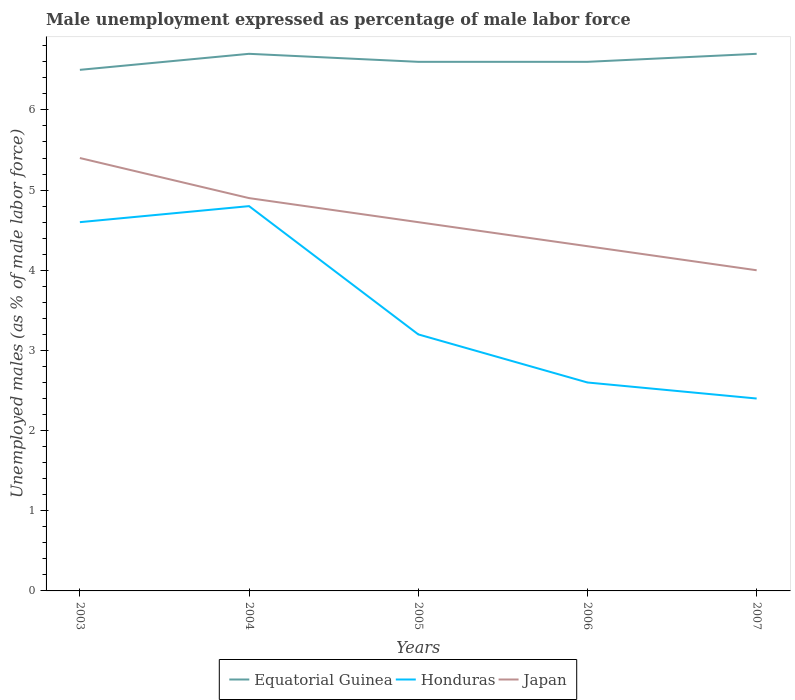Across all years, what is the maximum unemployment in males in in Honduras?
Offer a terse response. 2.4. What is the total unemployment in males in in Honduras in the graph?
Keep it short and to the point. 2.4. What is the difference between the highest and the second highest unemployment in males in in Equatorial Guinea?
Ensure brevity in your answer.  0.2. How many years are there in the graph?
Keep it short and to the point. 5. What is the difference between two consecutive major ticks on the Y-axis?
Make the answer very short. 1. Does the graph contain grids?
Keep it short and to the point. No. How many legend labels are there?
Make the answer very short. 3. How are the legend labels stacked?
Your answer should be compact. Horizontal. What is the title of the graph?
Give a very brief answer. Male unemployment expressed as percentage of male labor force. What is the label or title of the Y-axis?
Offer a very short reply. Unemployed males (as % of male labor force). What is the Unemployed males (as % of male labor force) in Equatorial Guinea in 2003?
Ensure brevity in your answer.  6.5. What is the Unemployed males (as % of male labor force) in Honduras in 2003?
Provide a succinct answer. 4.6. What is the Unemployed males (as % of male labor force) of Japan in 2003?
Make the answer very short. 5.4. What is the Unemployed males (as % of male labor force) of Equatorial Guinea in 2004?
Give a very brief answer. 6.7. What is the Unemployed males (as % of male labor force) in Honduras in 2004?
Give a very brief answer. 4.8. What is the Unemployed males (as % of male labor force) in Japan in 2004?
Make the answer very short. 4.9. What is the Unemployed males (as % of male labor force) in Equatorial Guinea in 2005?
Provide a succinct answer. 6.6. What is the Unemployed males (as % of male labor force) of Honduras in 2005?
Your answer should be compact. 3.2. What is the Unemployed males (as % of male labor force) of Japan in 2005?
Offer a very short reply. 4.6. What is the Unemployed males (as % of male labor force) of Equatorial Guinea in 2006?
Provide a short and direct response. 6.6. What is the Unemployed males (as % of male labor force) in Honduras in 2006?
Give a very brief answer. 2.6. What is the Unemployed males (as % of male labor force) of Japan in 2006?
Offer a very short reply. 4.3. What is the Unemployed males (as % of male labor force) in Equatorial Guinea in 2007?
Your answer should be compact. 6.7. What is the Unemployed males (as % of male labor force) in Honduras in 2007?
Give a very brief answer. 2.4. Across all years, what is the maximum Unemployed males (as % of male labor force) in Equatorial Guinea?
Offer a terse response. 6.7. Across all years, what is the maximum Unemployed males (as % of male labor force) in Honduras?
Offer a very short reply. 4.8. Across all years, what is the maximum Unemployed males (as % of male labor force) in Japan?
Offer a terse response. 5.4. Across all years, what is the minimum Unemployed males (as % of male labor force) in Equatorial Guinea?
Offer a terse response. 6.5. Across all years, what is the minimum Unemployed males (as % of male labor force) in Honduras?
Provide a succinct answer. 2.4. What is the total Unemployed males (as % of male labor force) in Equatorial Guinea in the graph?
Your answer should be compact. 33.1. What is the total Unemployed males (as % of male labor force) in Honduras in the graph?
Ensure brevity in your answer.  17.6. What is the total Unemployed males (as % of male labor force) of Japan in the graph?
Ensure brevity in your answer.  23.2. What is the difference between the Unemployed males (as % of male labor force) in Honduras in 2003 and that in 2004?
Your answer should be compact. -0.2. What is the difference between the Unemployed males (as % of male labor force) in Japan in 2003 and that in 2004?
Make the answer very short. 0.5. What is the difference between the Unemployed males (as % of male labor force) of Honduras in 2003 and that in 2005?
Offer a terse response. 1.4. What is the difference between the Unemployed males (as % of male labor force) in Honduras in 2003 and that in 2006?
Offer a terse response. 2. What is the difference between the Unemployed males (as % of male labor force) of Japan in 2003 and that in 2006?
Give a very brief answer. 1.1. What is the difference between the Unemployed males (as % of male labor force) in Japan in 2003 and that in 2007?
Offer a very short reply. 1.4. What is the difference between the Unemployed males (as % of male labor force) of Equatorial Guinea in 2004 and that in 2005?
Give a very brief answer. 0.1. What is the difference between the Unemployed males (as % of male labor force) in Equatorial Guinea in 2004 and that in 2006?
Offer a terse response. 0.1. What is the difference between the Unemployed males (as % of male labor force) in Equatorial Guinea in 2004 and that in 2007?
Ensure brevity in your answer.  0. What is the difference between the Unemployed males (as % of male labor force) in Honduras in 2004 and that in 2007?
Give a very brief answer. 2.4. What is the difference between the Unemployed males (as % of male labor force) in Japan in 2004 and that in 2007?
Keep it short and to the point. 0.9. What is the difference between the Unemployed males (as % of male labor force) of Equatorial Guinea in 2005 and that in 2006?
Offer a terse response. 0. What is the difference between the Unemployed males (as % of male labor force) of Equatorial Guinea in 2005 and that in 2007?
Ensure brevity in your answer.  -0.1. What is the difference between the Unemployed males (as % of male labor force) of Equatorial Guinea in 2006 and that in 2007?
Offer a very short reply. -0.1. What is the difference between the Unemployed males (as % of male labor force) of Honduras in 2006 and that in 2007?
Offer a very short reply. 0.2. What is the difference between the Unemployed males (as % of male labor force) of Japan in 2006 and that in 2007?
Your answer should be very brief. 0.3. What is the difference between the Unemployed males (as % of male labor force) in Honduras in 2003 and the Unemployed males (as % of male labor force) in Japan in 2004?
Your answer should be very brief. -0.3. What is the difference between the Unemployed males (as % of male labor force) in Equatorial Guinea in 2003 and the Unemployed males (as % of male labor force) in Honduras in 2005?
Offer a very short reply. 3.3. What is the difference between the Unemployed males (as % of male labor force) of Equatorial Guinea in 2003 and the Unemployed males (as % of male labor force) of Japan in 2005?
Provide a short and direct response. 1.9. What is the difference between the Unemployed males (as % of male labor force) of Equatorial Guinea in 2003 and the Unemployed males (as % of male labor force) of Honduras in 2007?
Offer a terse response. 4.1. What is the difference between the Unemployed males (as % of male labor force) of Equatorial Guinea in 2003 and the Unemployed males (as % of male labor force) of Japan in 2007?
Provide a short and direct response. 2.5. What is the difference between the Unemployed males (as % of male labor force) in Honduras in 2003 and the Unemployed males (as % of male labor force) in Japan in 2007?
Ensure brevity in your answer.  0.6. What is the difference between the Unemployed males (as % of male labor force) of Equatorial Guinea in 2004 and the Unemployed males (as % of male labor force) of Honduras in 2006?
Make the answer very short. 4.1. What is the difference between the Unemployed males (as % of male labor force) in Equatorial Guinea in 2004 and the Unemployed males (as % of male labor force) in Japan in 2006?
Make the answer very short. 2.4. What is the difference between the Unemployed males (as % of male labor force) in Equatorial Guinea in 2004 and the Unemployed males (as % of male labor force) in Honduras in 2007?
Give a very brief answer. 4.3. What is the difference between the Unemployed males (as % of male labor force) in Honduras in 2004 and the Unemployed males (as % of male labor force) in Japan in 2007?
Provide a succinct answer. 0.8. What is the difference between the Unemployed males (as % of male labor force) of Equatorial Guinea in 2005 and the Unemployed males (as % of male labor force) of Japan in 2006?
Provide a succinct answer. 2.3. What is the difference between the Unemployed males (as % of male labor force) in Honduras in 2005 and the Unemployed males (as % of male labor force) in Japan in 2006?
Your response must be concise. -1.1. What is the difference between the Unemployed males (as % of male labor force) of Equatorial Guinea in 2005 and the Unemployed males (as % of male labor force) of Japan in 2007?
Offer a terse response. 2.6. What is the difference between the Unemployed males (as % of male labor force) in Honduras in 2005 and the Unemployed males (as % of male labor force) in Japan in 2007?
Provide a succinct answer. -0.8. What is the difference between the Unemployed males (as % of male labor force) of Equatorial Guinea in 2006 and the Unemployed males (as % of male labor force) of Honduras in 2007?
Ensure brevity in your answer.  4.2. What is the difference between the Unemployed males (as % of male labor force) in Equatorial Guinea in 2006 and the Unemployed males (as % of male labor force) in Japan in 2007?
Offer a very short reply. 2.6. What is the difference between the Unemployed males (as % of male labor force) in Honduras in 2006 and the Unemployed males (as % of male labor force) in Japan in 2007?
Give a very brief answer. -1.4. What is the average Unemployed males (as % of male labor force) of Equatorial Guinea per year?
Make the answer very short. 6.62. What is the average Unemployed males (as % of male labor force) of Honduras per year?
Provide a succinct answer. 3.52. What is the average Unemployed males (as % of male labor force) in Japan per year?
Make the answer very short. 4.64. In the year 2003, what is the difference between the Unemployed males (as % of male labor force) in Equatorial Guinea and Unemployed males (as % of male labor force) in Honduras?
Your answer should be compact. 1.9. In the year 2003, what is the difference between the Unemployed males (as % of male labor force) in Honduras and Unemployed males (as % of male labor force) in Japan?
Offer a terse response. -0.8. In the year 2004, what is the difference between the Unemployed males (as % of male labor force) in Equatorial Guinea and Unemployed males (as % of male labor force) in Japan?
Make the answer very short. 1.8. In the year 2004, what is the difference between the Unemployed males (as % of male labor force) in Honduras and Unemployed males (as % of male labor force) in Japan?
Your answer should be very brief. -0.1. In the year 2005, what is the difference between the Unemployed males (as % of male labor force) in Equatorial Guinea and Unemployed males (as % of male labor force) in Honduras?
Offer a very short reply. 3.4. In the year 2005, what is the difference between the Unemployed males (as % of male labor force) in Equatorial Guinea and Unemployed males (as % of male labor force) in Japan?
Give a very brief answer. 2. In the year 2006, what is the difference between the Unemployed males (as % of male labor force) of Equatorial Guinea and Unemployed males (as % of male labor force) of Honduras?
Your answer should be compact. 4. In the year 2006, what is the difference between the Unemployed males (as % of male labor force) in Honduras and Unemployed males (as % of male labor force) in Japan?
Ensure brevity in your answer.  -1.7. In the year 2007, what is the difference between the Unemployed males (as % of male labor force) in Equatorial Guinea and Unemployed males (as % of male labor force) in Honduras?
Your response must be concise. 4.3. In the year 2007, what is the difference between the Unemployed males (as % of male labor force) in Equatorial Guinea and Unemployed males (as % of male labor force) in Japan?
Give a very brief answer. 2.7. In the year 2007, what is the difference between the Unemployed males (as % of male labor force) in Honduras and Unemployed males (as % of male labor force) in Japan?
Ensure brevity in your answer.  -1.6. What is the ratio of the Unemployed males (as % of male labor force) in Equatorial Guinea in 2003 to that in 2004?
Your answer should be very brief. 0.97. What is the ratio of the Unemployed males (as % of male labor force) in Japan in 2003 to that in 2004?
Your answer should be compact. 1.1. What is the ratio of the Unemployed males (as % of male labor force) of Honduras in 2003 to that in 2005?
Provide a short and direct response. 1.44. What is the ratio of the Unemployed males (as % of male labor force) in Japan in 2003 to that in 2005?
Provide a succinct answer. 1.17. What is the ratio of the Unemployed males (as % of male labor force) of Equatorial Guinea in 2003 to that in 2006?
Make the answer very short. 0.98. What is the ratio of the Unemployed males (as % of male labor force) of Honduras in 2003 to that in 2006?
Your answer should be compact. 1.77. What is the ratio of the Unemployed males (as % of male labor force) in Japan in 2003 to that in 2006?
Provide a succinct answer. 1.26. What is the ratio of the Unemployed males (as % of male labor force) of Equatorial Guinea in 2003 to that in 2007?
Keep it short and to the point. 0.97. What is the ratio of the Unemployed males (as % of male labor force) in Honduras in 2003 to that in 2007?
Provide a succinct answer. 1.92. What is the ratio of the Unemployed males (as % of male labor force) in Japan in 2003 to that in 2007?
Provide a short and direct response. 1.35. What is the ratio of the Unemployed males (as % of male labor force) in Equatorial Guinea in 2004 to that in 2005?
Offer a very short reply. 1.02. What is the ratio of the Unemployed males (as % of male labor force) in Honduras in 2004 to that in 2005?
Give a very brief answer. 1.5. What is the ratio of the Unemployed males (as % of male labor force) in Japan in 2004 to that in 2005?
Give a very brief answer. 1.07. What is the ratio of the Unemployed males (as % of male labor force) of Equatorial Guinea in 2004 to that in 2006?
Ensure brevity in your answer.  1.02. What is the ratio of the Unemployed males (as % of male labor force) of Honduras in 2004 to that in 2006?
Your answer should be compact. 1.85. What is the ratio of the Unemployed males (as % of male labor force) in Japan in 2004 to that in 2006?
Give a very brief answer. 1.14. What is the ratio of the Unemployed males (as % of male labor force) of Japan in 2004 to that in 2007?
Your answer should be compact. 1.23. What is the ratio of the Unemployed males (as % of male labor force) of Equatorial Guinea in 2005 to that in 2006?
Give a very brief answer. 1. What is the ratio of the Unemployed males (as % of male labor force) in Honduras in 2005 to that in 2006?
Your answer should be compact. 1.23. What is the ratio of the Unemployed males (as % of male labor force) in Japan in 2005 to that in 2006?
Provide a short and direct response. 1.07. What is the ratio of the Unemployed males (as % of male labor force) of Equatorial Guinea in 2005 to that in 2007?
Offer a terse response. 0.99. What is the ratio of the Unemployed males (as % of male labor force) in Japan in 2005 to that in 2007?
Your answer should be very brief. 1.15. What is the ratio of the Unemployed males (as % of male labor force) of Equatorial Guinea in 2006 to that in 2007?
Your response must be concise. 0.99. What is the ratio of the Unemployed males (as % of male labor force) of Honduras in 2006 to that in 2007?
Your answer should be compact. 1.08. What is the ratio of the Unemployed males (as % of male labor force) in Japan in 2006 to that in 2007?
Keep it short and to the point. 1.07. What is the difference between the highest and the second highest Unemployed males (as % of male labor force) of Honduras?
Make the answer very short. 0.2. What is the difference between the highest and the second highest Unemployed males (as % of male labor force) of Japan?
Your answer should be compact. 0.5. What is the difference between the highest and the lowest Unemployed males (as % of male labor force) in Honduras?
Offer a terse response. 2.4. What is the difference between the highest and the lowest Unemployed males (as % of male labor force) of Japan?
Provide a short and direct response. 1.4. 